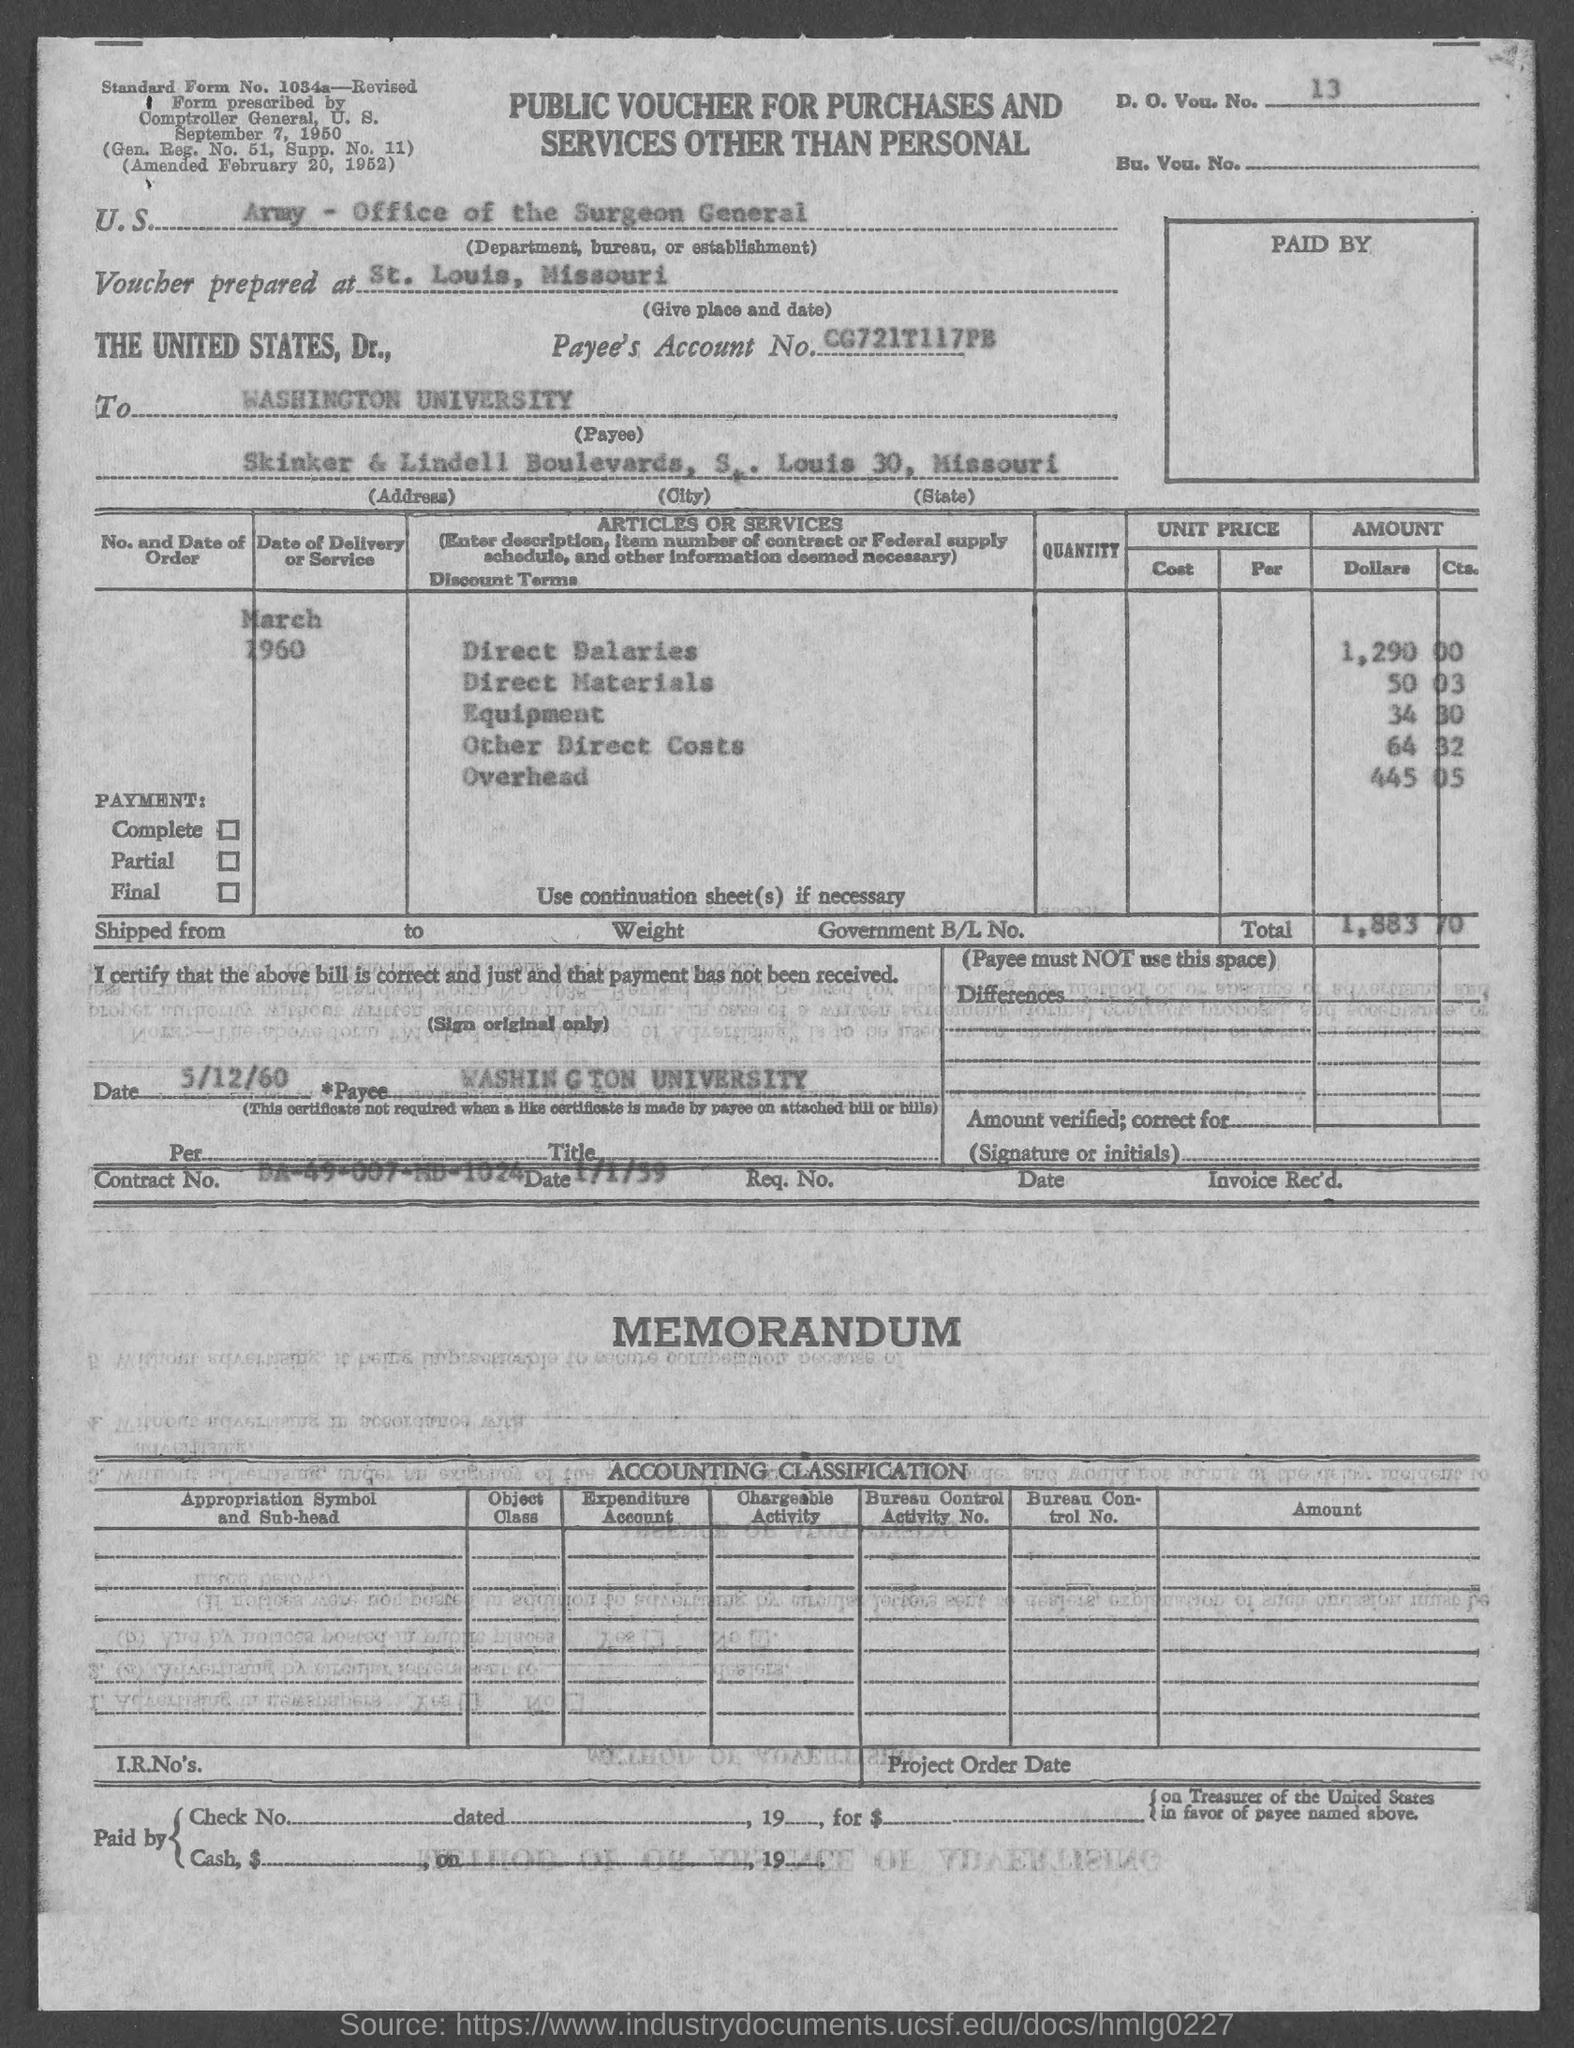Point out several critical features in this image. The equipment cost stated in the voucher is $34.30. The payee's account number as listed in the voucher is CG721T117PB... The total amount mentioned in the voucher is 1,883.70. The document contains a D.O.V. number of 13.. The payee name listed in the voucher is Washington University... 